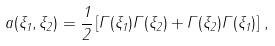<formula> <loc_0><loc_0><loc_500><loc_500>a ( \xi _ { 1 } , \xi _ { 2 } ) = \frac { 1 } { 2 } \left [ \Gamma ( \xi _ { 1 } ) \Gamma ( \xi _ { 2 } ) + \Gamma ( \xi _ { 2 } ) \Gamma ( \xi _ { 1 } ) \right ] \, ,</formula> 